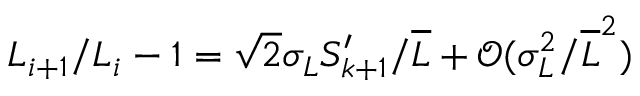Convert formula to latex. <formula><loc_0><loc_0><loc_500><loc_500>L _ { i + 1 } / L _ { i } - 1 = \sqrt { 2 } \sigma _ { L } S _ { k + 1 } ^ { \prime } / \overline { L } + \mathcal { O } ( \sigma _ { L } ^ { 2 } / \overline { L } ^ { 2 } )</formula> 